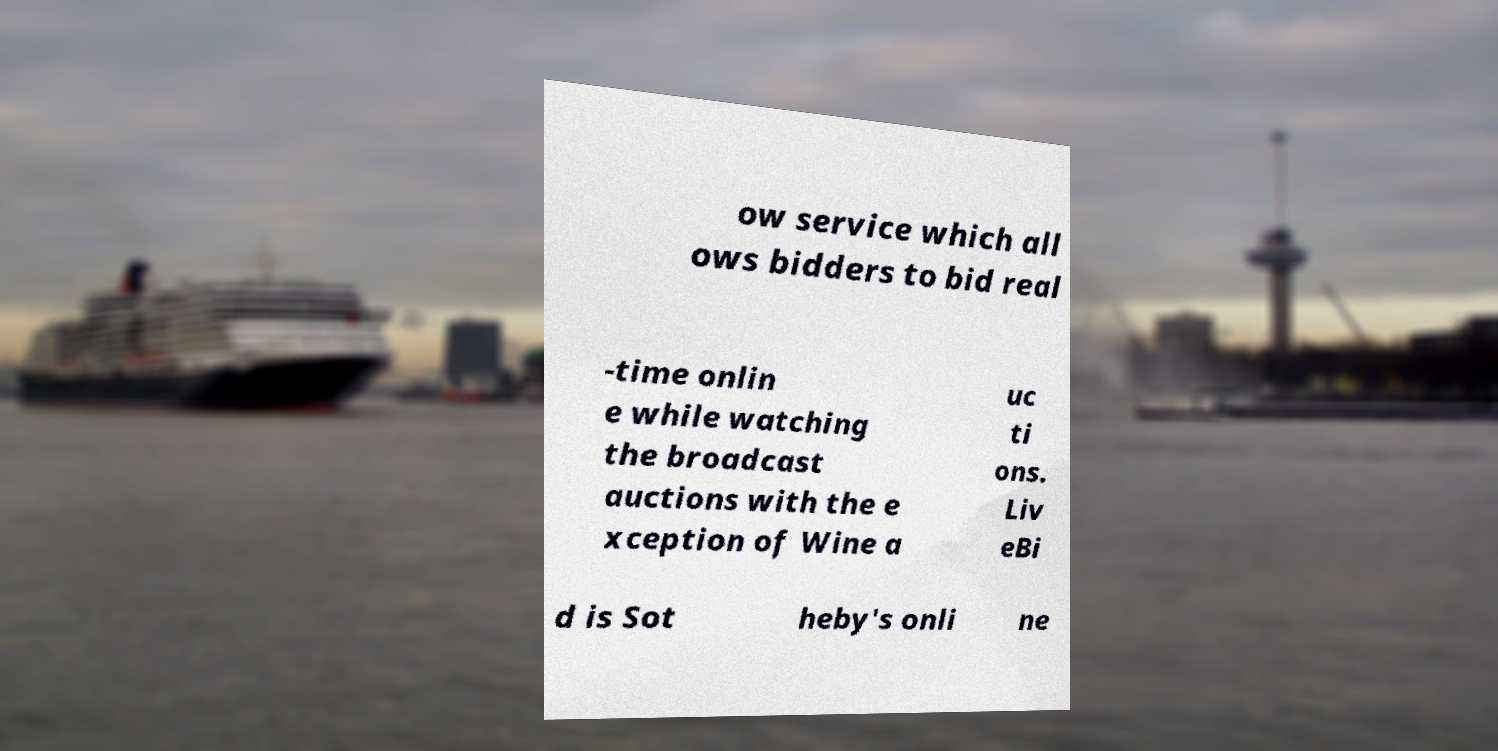Could you assist in decoding the text presented in this image and type it out clearly? ow service which all ows bidders to bid real -time onlin e while watching the broadcast auctions with the e xception of Wine a uc ti ons. Liv eBi d is Sot heby's onli ne 